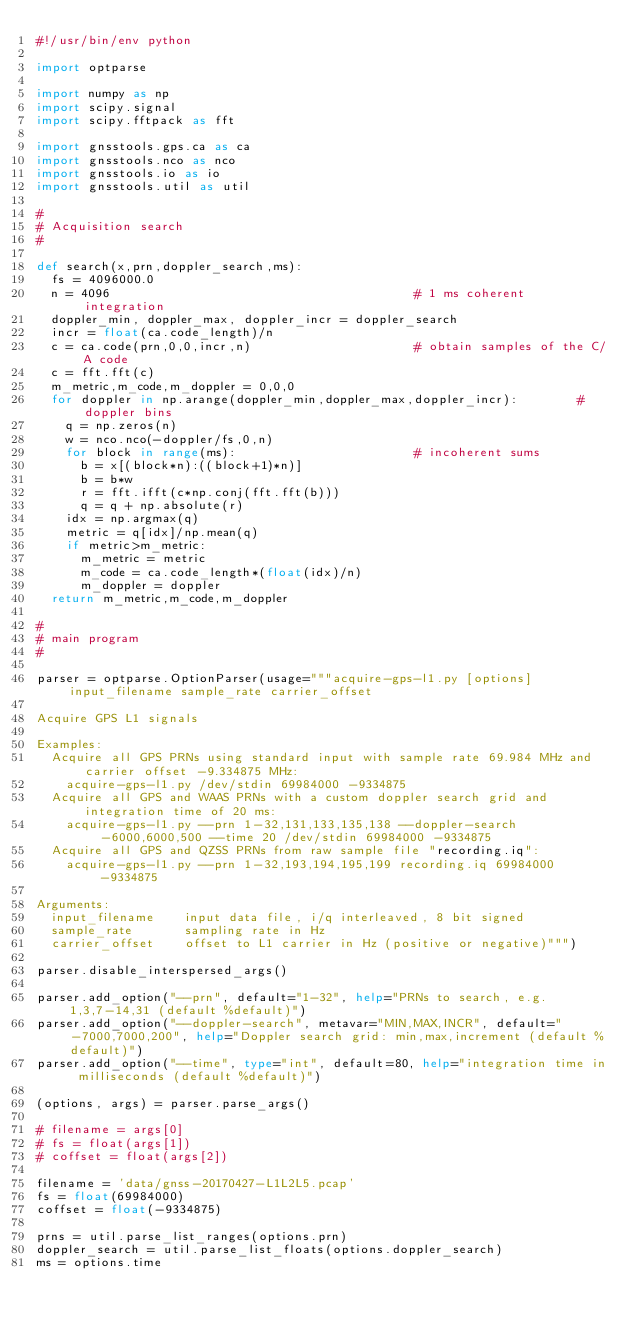Convert code to text. <code><loc_0><loc_0><loc_500><loc_500><_Python_>#!/usr/bin/env python

import optparse

import numpy as np
import scipy.signal
import scipy.fftpack as fft

import gnsstools.gps.ca as ca
import gnsstools.nco as nco
import gnsstools.io as io
import gnsstools.util as util

#
# Acquisition search
#

def search(x,prn,doppler_search,ms):
  fs = 4096000.0
  n = 4096                                         # 1 ms coherent integration
  doppler_min, doppler_max, doppler_incr = doppler_search
  incr = float(ca.code_length)/n
  c = ca.code(prn,0,0,incr,n)                      # obtain samples of the C/A code
  c = fft.fft(c)
  m_metric,m_code,m_doppler = 0,0,0
  for doppler in np.arange(doppler_min,doppler_max,doppler_incr):        # doppler bins
    q = np.zeros(n)
    w = nco.nco(-doppler/fs,0,n)
    for block in range(ms):                        # incoherent sums
      b = x[(block*n):((block+1)*n)]
      b = b*w
      r = fft.ifft(c*np.conj(fft.fft(b)))
      q = q + np.absolute(r)
    idx = np.argmax(q)
    metric = q[idx]/np.mean(q)
    if metric>m_metric:
      m_metric = metric
      m_code = ca.code_length*(float(idx)/n)
      m_doppler = doppler
  return m_metric,m_code,m_doppler

#
# main program
#

parser = optparse.OptionParser(usage="""acquire-gps-l1.py [options] input_filename sample_rate carrier_offset

Acquire GPS L1 signals

Examples:
  Acquire all GPS PRNs using standard input with sample rate 69.984 MHz and carrier offset -9.334875 MHz:
    acquire-gps-l1.py /dev/stdin 69984000 -9334875
  Acquire all GPS and WAAS PRNs with a custom doppler search grid and integration time of 20 ms:
    acquire-gps-l1.py --prn 1-32,131,133,135,138 --doppler-search -6000,6000,500 --time 20 /dev/stdin 69984000 -9334875
  Acquire all GPS and QZSS PRNs from raw sample file "recording.iq":
    acquire-gps-l1.py --prn 1-32,193,194,195,199 recording.iq 69984000 -9334875

Arguments:
  input_filename    input data file, i/q interleaved, 8 bit signed
  sample_rate       sampling rate in Hz
  carrier_offset    offset to L1 carrier in Hz (positive or negative)""")

parser.disable_interspersed_args()

parser.add_option("--prn", default="1-32", help="PRNs to search, e.g. 1,3,7-14,31 (default %default)")
parser.add_option("--doppler-search", metavar="MIN,MAX,INCR", default="-7000,7000,200", help="Doppler search grid: min,max,increment (default %default)")
parser.add_option("--time", type="int", default=80, help="integration time in milliseconds (default %default)")

(options, args) = parser.parse_args()

# filename = args[0]
# fs = float(args[1])
# coffset = float(args[2])

filename = 'data/gnss-20170427-L1L2L5.pcap'
fs = float(69984000)
coffset = float(-9334875)

prns = util.parse_list_ranges(options.prn)
doppler_search = util.parse_list_floats(options.doppler_search)
ms = options.time
</code> 